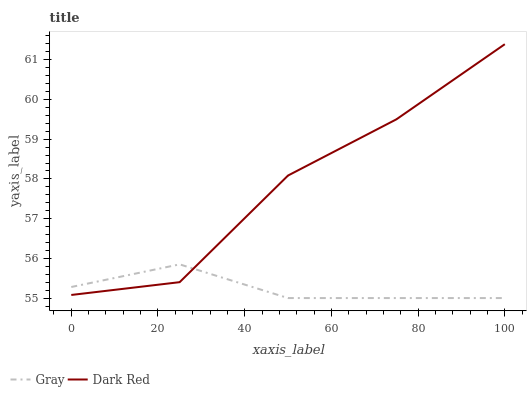Does Gray have the minimum area under the curve?
Answer yes or no. Yes. Does Dark Red have the maximum area under the curve?
Answer yes or no. Yes. Does Dark Red have the minimum area under the curve?
Answer yes or no. No. Is Gray the smoothest?
Answer yes or no. Yes. Is Dark Red the roughest?
Answer yes or no. Yes. Is Dark Red the smoothest?
Answer yes or no. No. Does Gray have the lowest value?
Answer yes or no. Yes. Does Dark Red have the lowest value?
Answer yes or no. No. Does Dark Red have the highest value?
Answer yes or no. Yes. Does Dark Red intersect Gray?
Answer yes or no. Yes. Is Dark Red less than Gray?
Answer yes or no. No. Is Dark Red greater than Gray?
Answer yes or no. No. 